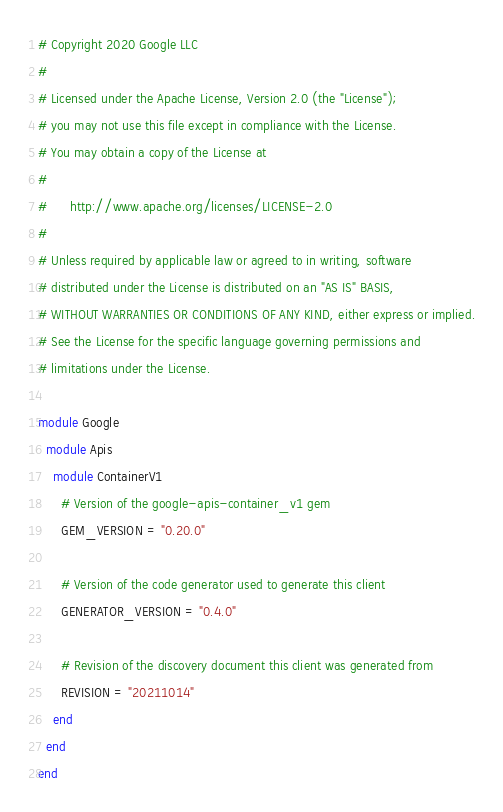Convert code to text. <code><loc_0><loc_0><loc_500><loc_500><_Ruby_># Copyright 2020 Google LLC
#
# Licensed under the Apache License, Version 2.0 (the "License");
# you may not use this file except in compliance with the License.
# You may obtain a copy of the License at
#
#      http://www.apache.org/licenses/LICENSE-2.0
#
# Unless required by applicable law or agreed to in writing, software
# distributed under the License is distributed on an "AS IS" BASIS,
# WITHOUT WARRANTIES OR CONDITIONS OF ANY KIND, either express or implied.
# See the License for the specific language governing permissions and
# limitations under the License.

module Google
  module Apis
    module ContainerV1
      # Version of the google-apis-container_v1 gem
      GEM_VERSION = "0.20.0"

      # Version of the code generator used to generate this client
      GENERATOR_VERSION = "0.4.0"

      # Revision of the discovery document this client was generated from
      REVISION = "20211014"
    end
  end
end
</code> 